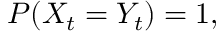Convert formula to latex. <formula><loc_0><loc_0><loc_500><loc_500>P ( X _ { t } = Y _ { t } ) = 1 ,</formula> 